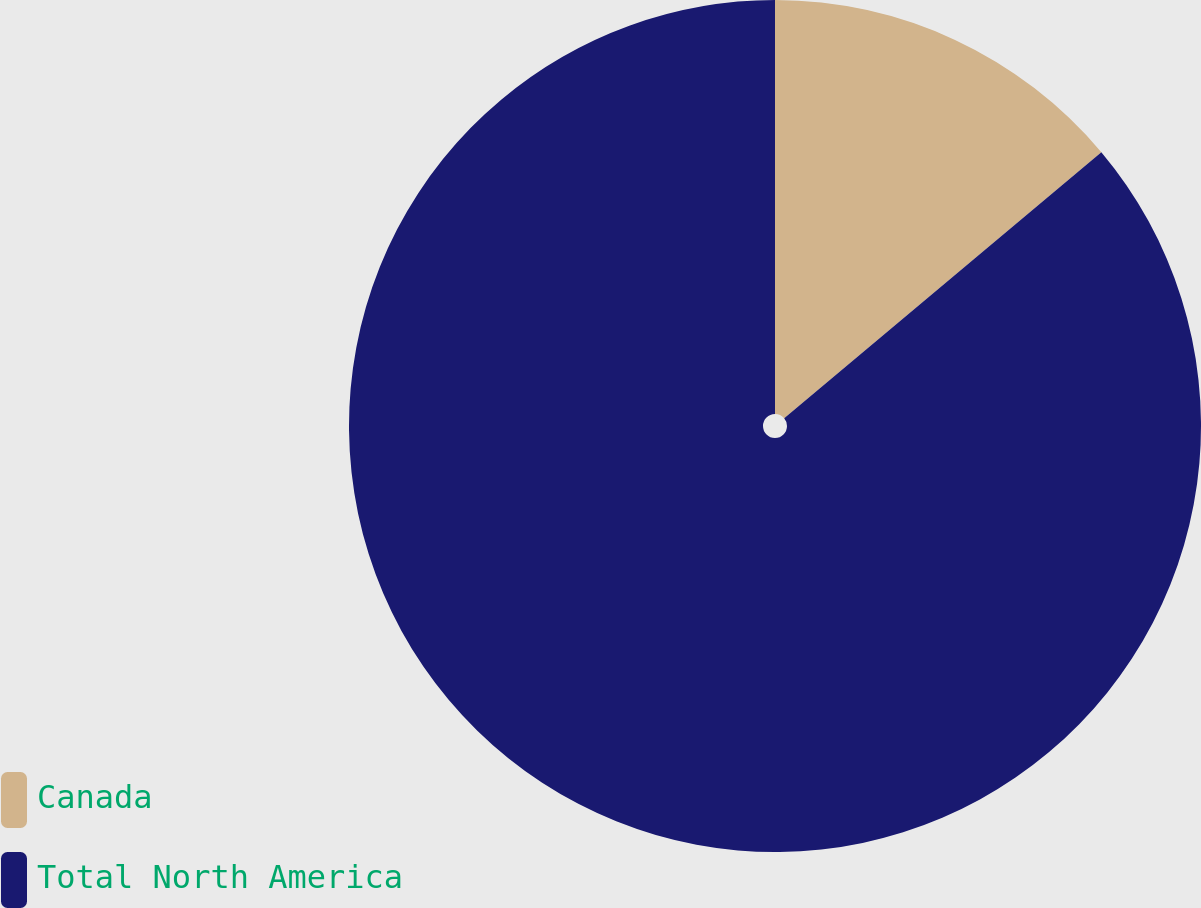<chart> <loc_0><loc_0><loc_500><loc_500><pie_chart><fcel>Canada<fcel>Total North America<nl><fcel>13.89%<fcel>86.11%<nl></chart> 